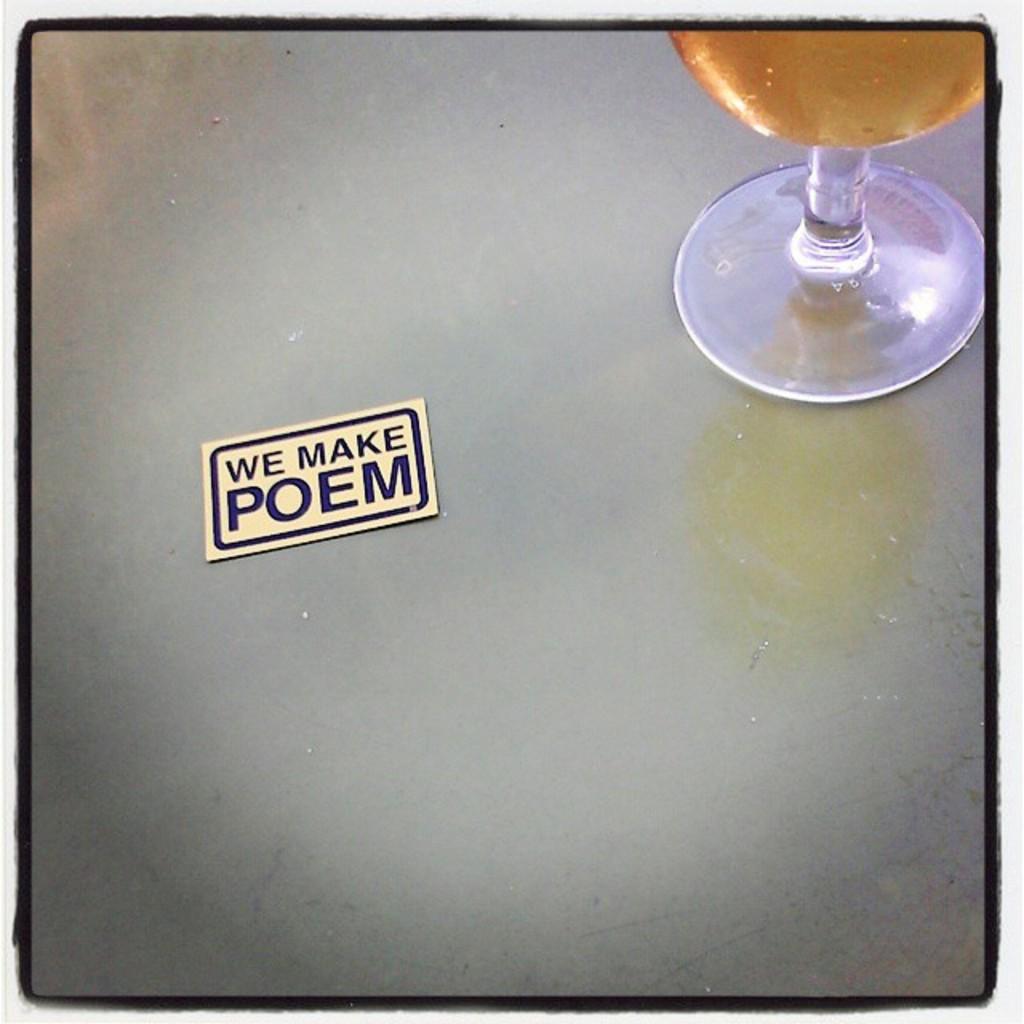What does the sticker say?
Your answer should be compact. We make poem. 